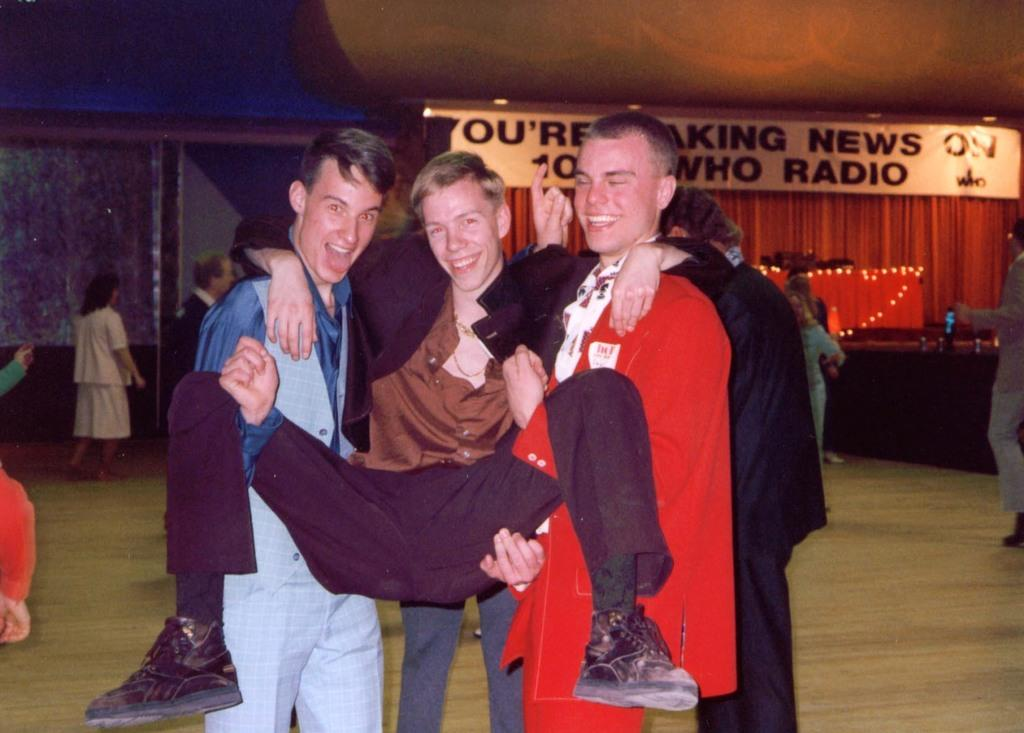What is the main subject of the image? The main subject of the image is the boys in the center. Can you describe the background of the image? There are other people in the background of the image. What is located at the top side of the image? There is a flex at the top side of the image. What type of silk is being used by the boys in the image? There is no silk present in the image, and the boys are not using any silk. 